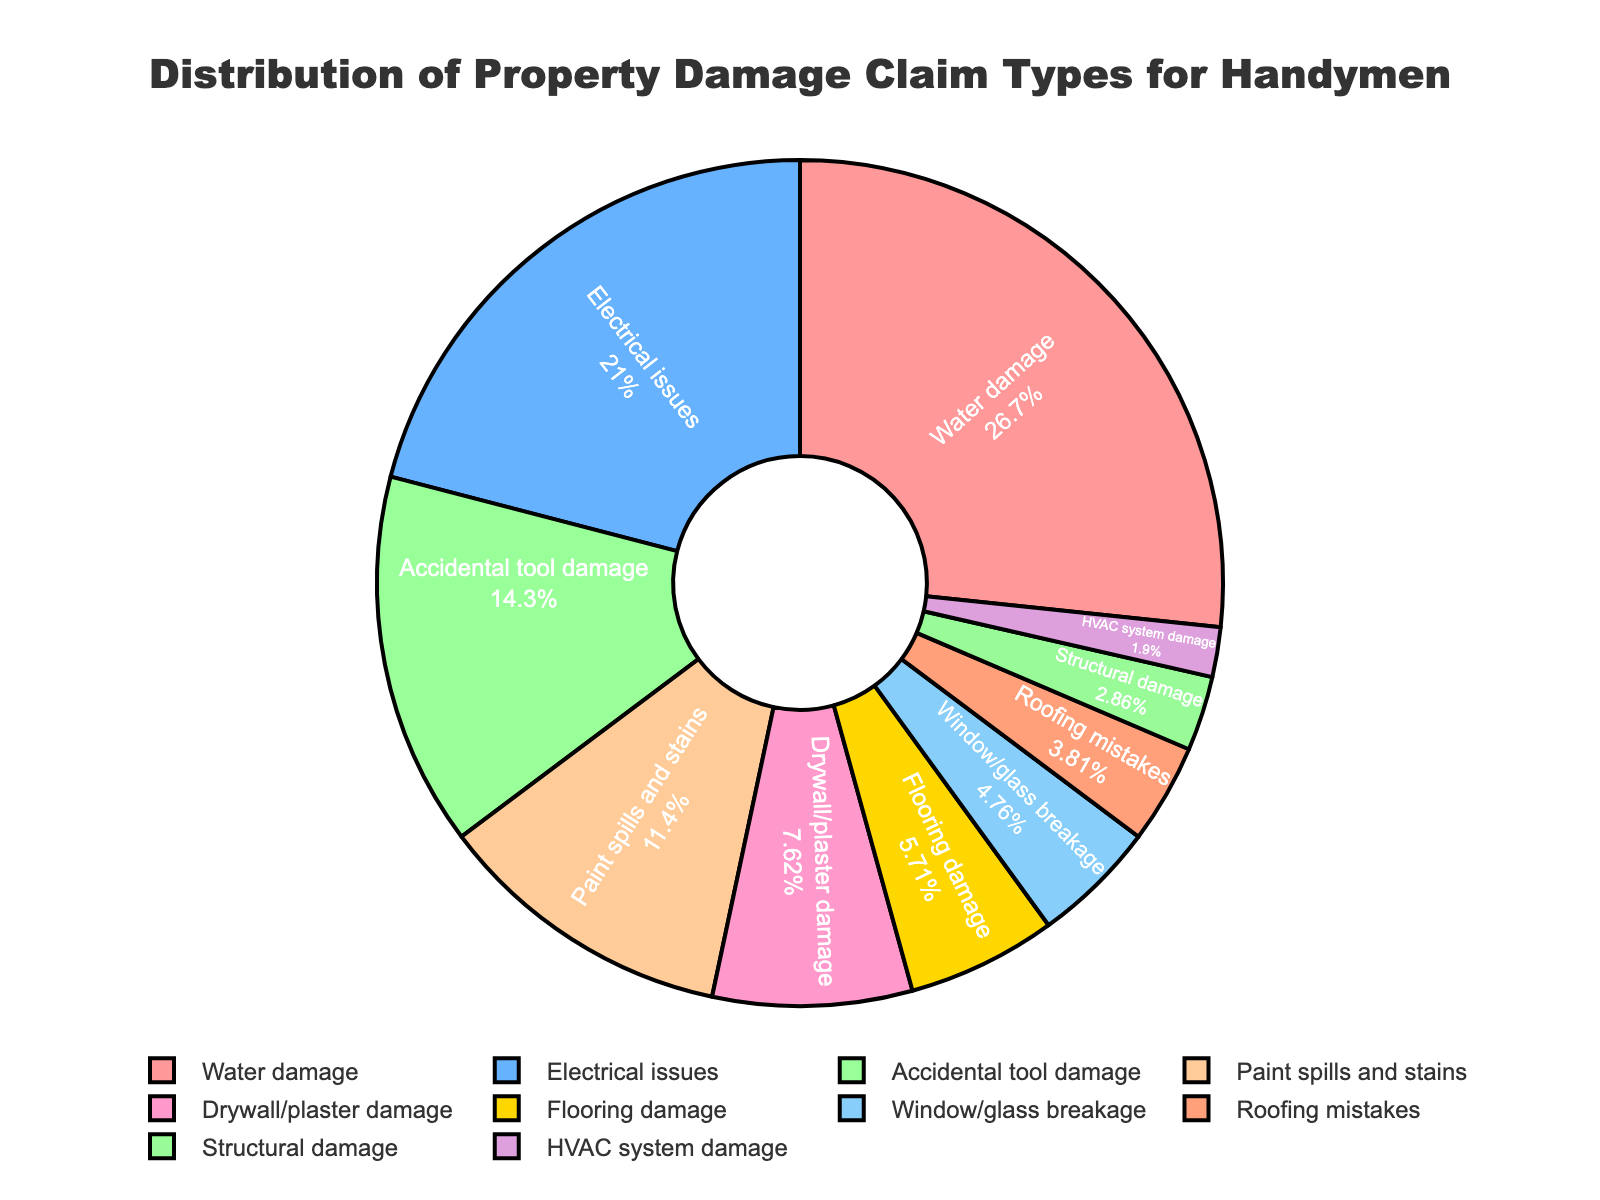What's the most common type of property damage claim for handymen? The largest segment in the pie chart represents Water damage, which makes up 28% of the total claims.
Answer: Water damage Which category has the smallest percentage of claims? The smallest segment in the pie chart represents HVAC system damage, which accounts for 2% of the total claims.
Answer: HVAC system damage What is the total percentage of claims for Electrical issues and Accidental tool damage combined? Electrical issues account for 22% and Accidental tool damage accounts for 15%. Adding these percentages: 22% + 15% = 37%.
Answer: 37% How does the percentage of Flooring damage compare to Roof mistakes? Flooring damage accounts for 6% and Roofing mistakes account for 4%. 6% is higher than 4%.
Answer: Flooring damage is higher Which three categories account for more than 20% of claims each? The segments representing Water damage, Electrical issues, and Accidental tool damage each account for more than 20% (28%, 22%, and 15% respectively). However, only Water damage and Electrical issues are above 20%.
Answer: Water damage, Electrical issues 